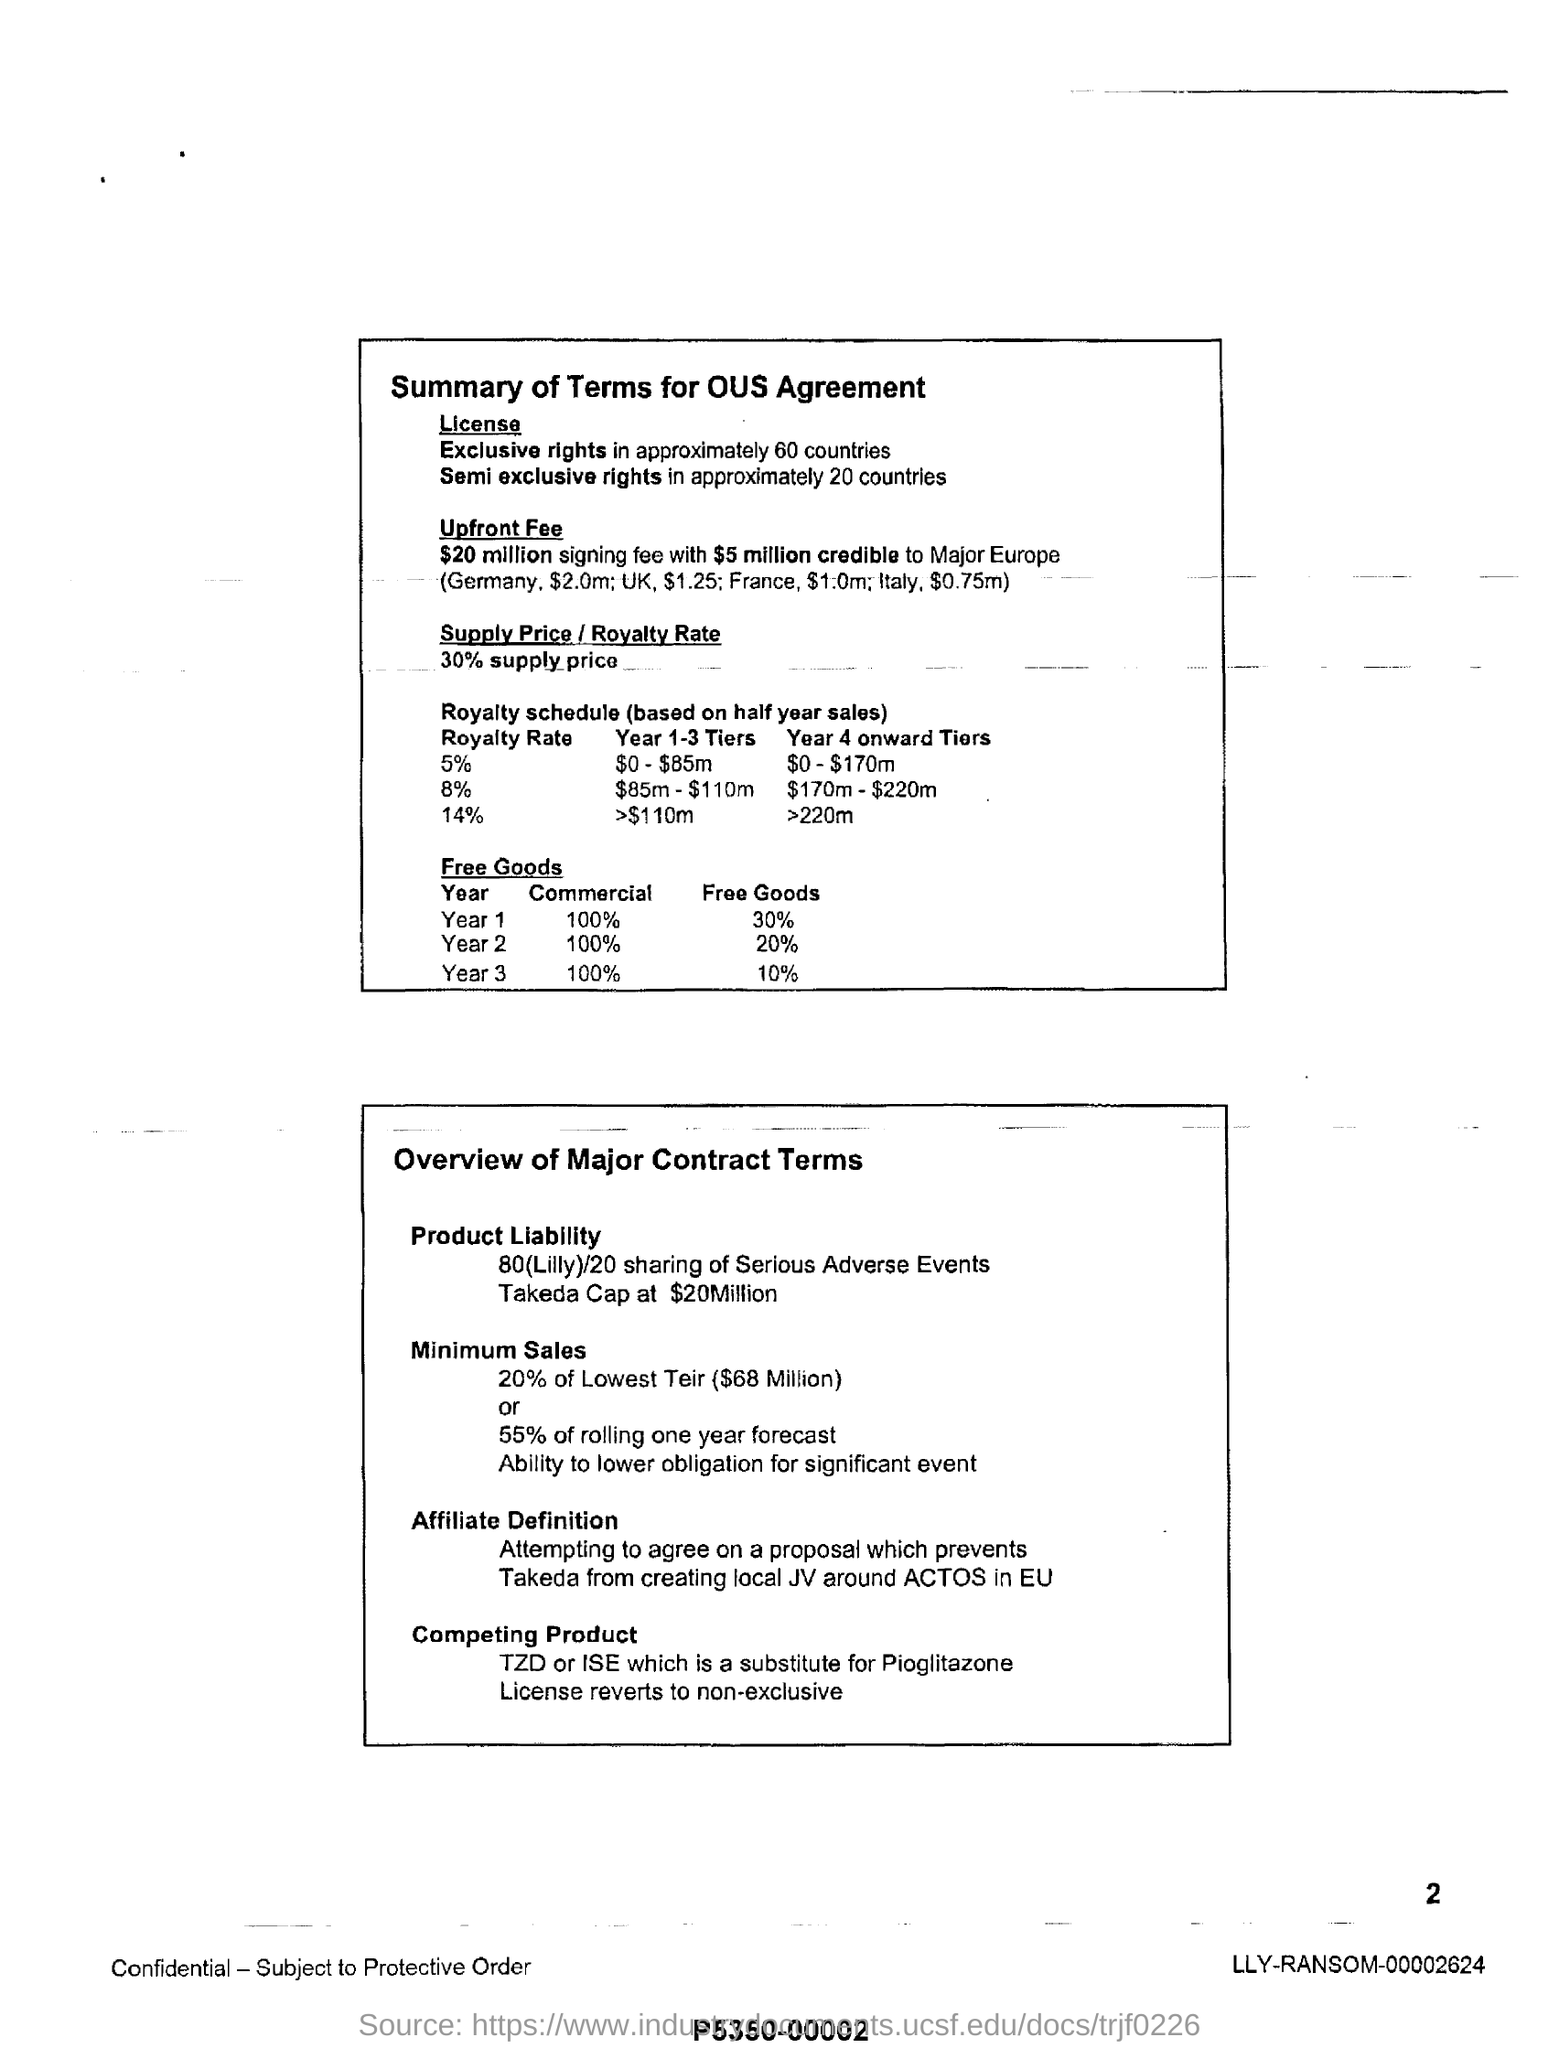Specify some key components in this picture. The supply price is 30% of the royalty rate. In approximately 60 countries, exclusive rights are granted through a license. Semi exclusive rights have been granted in 20 countries. 